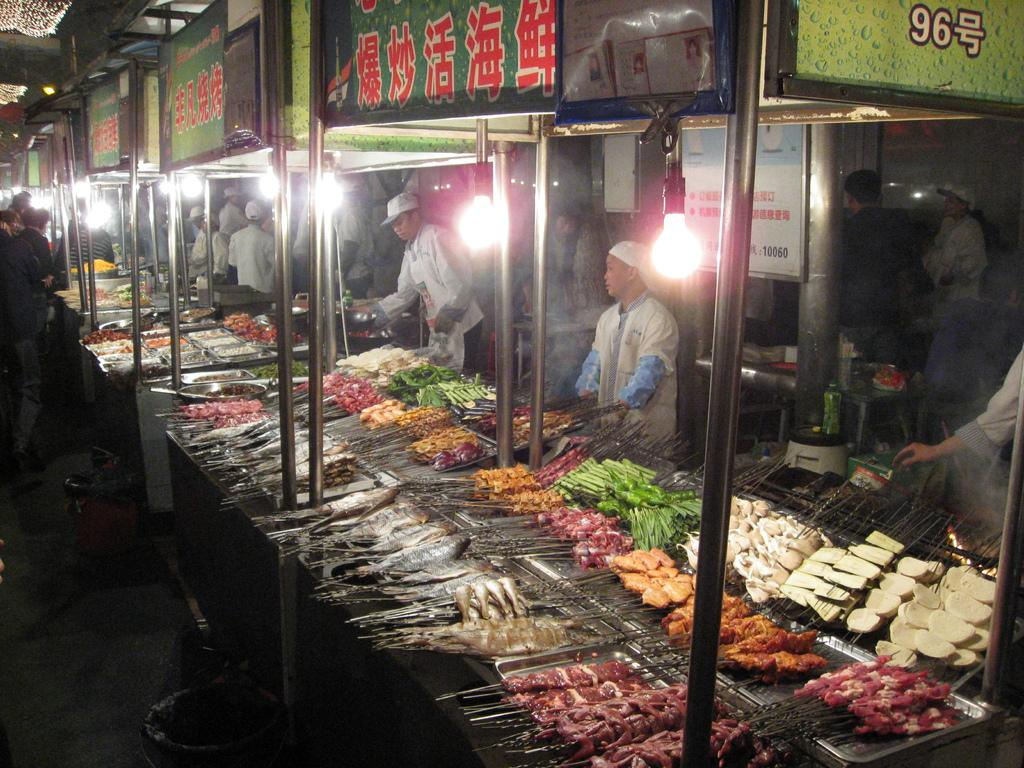What type of establishments can be seen in the image? There are food stalls in the image. Are there any people present in the image? Yes, there are persons standing in the image. What type of tent is visible in the image? There is no tent present in the image. How do the people in the image express disgust? There is no indication of disgust in the image; the people are simply standing. 